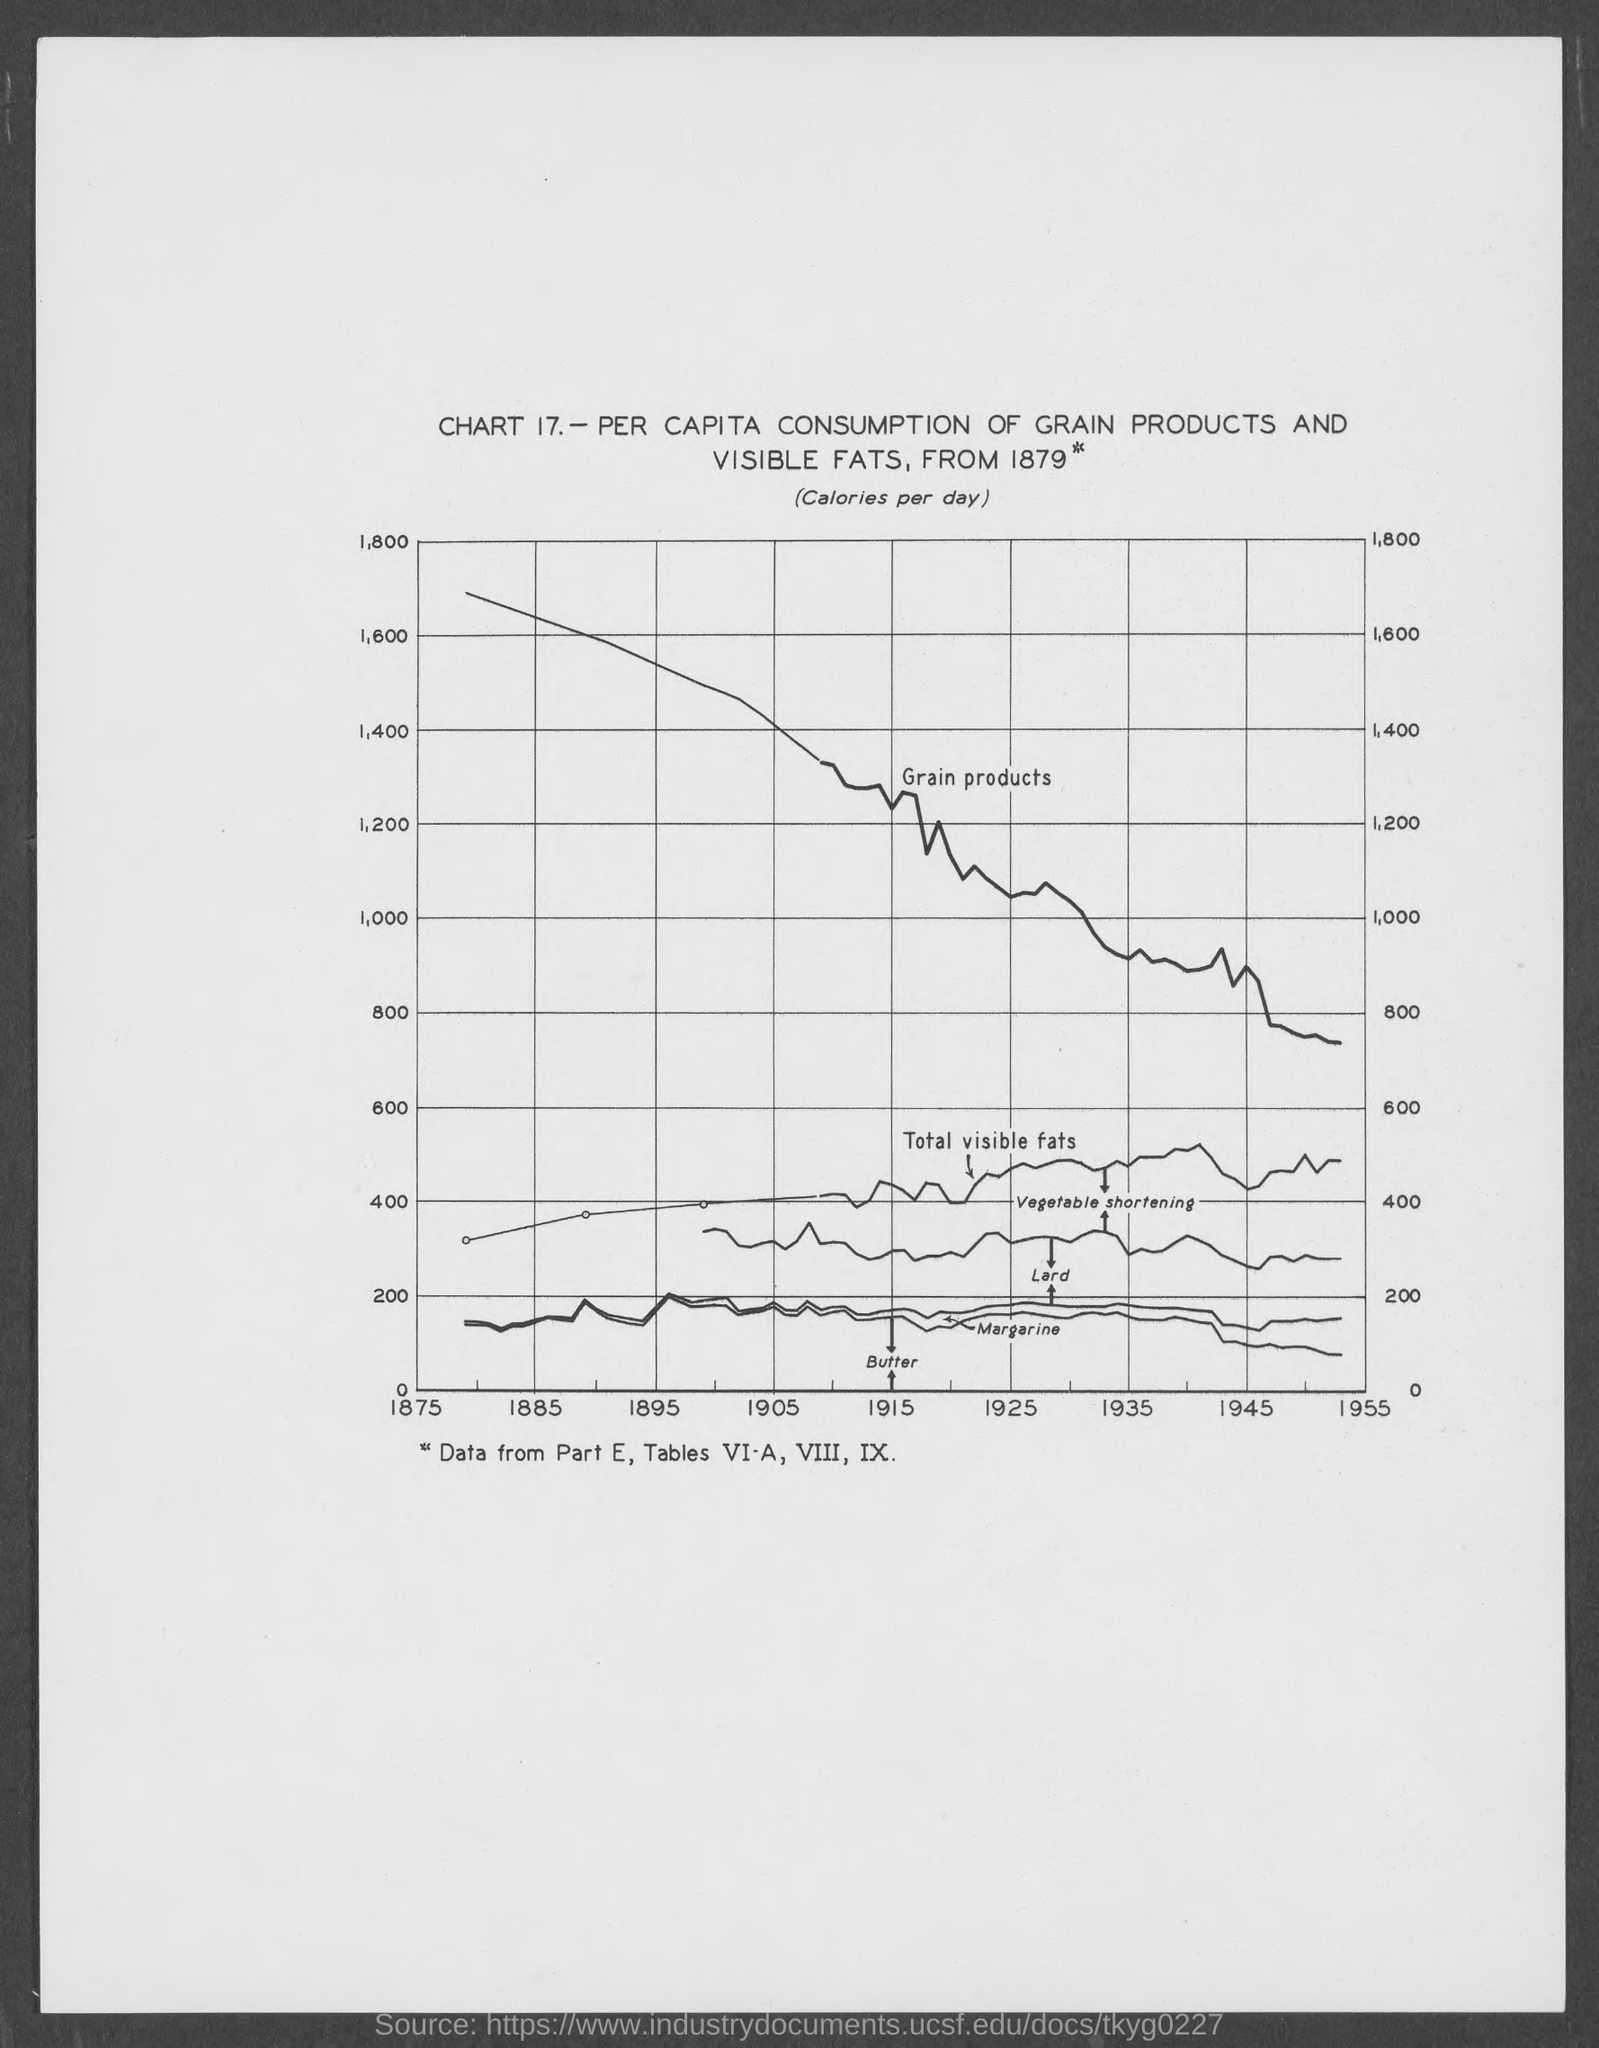List a handful of essential elements in this visual. The chart number is 17. 